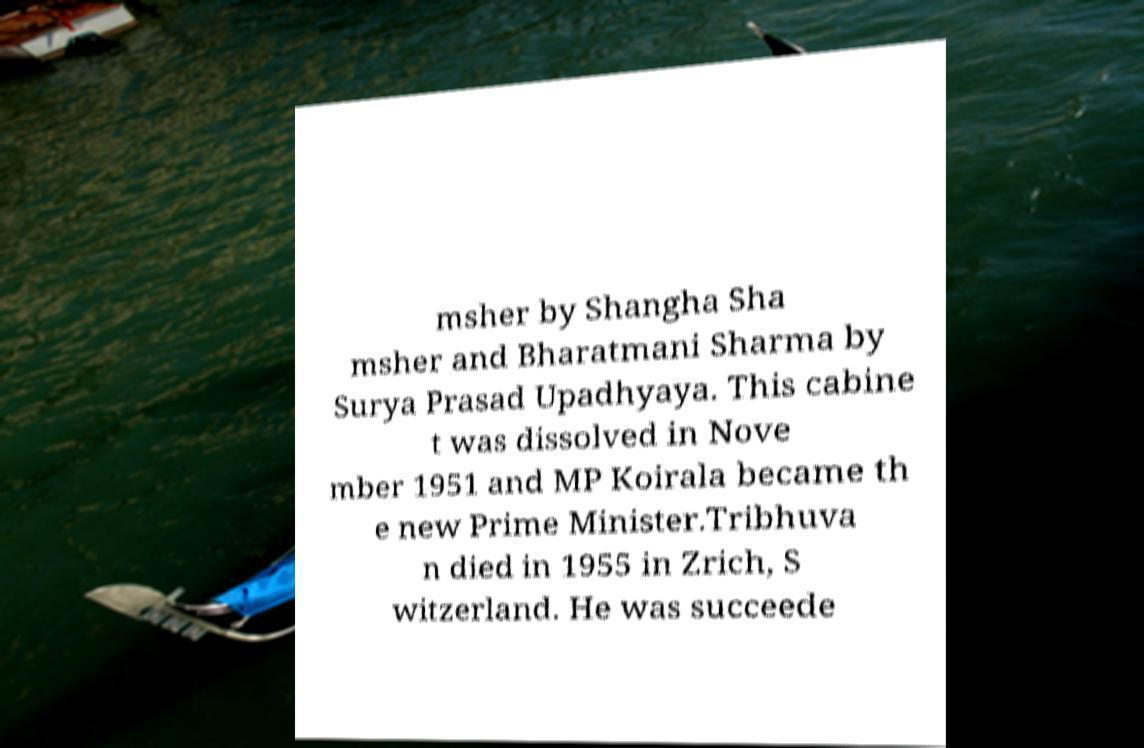Could you extract and type out the text from this image? msher by Shangha Sha msher and Bharatmani Sharma by Surya Prasad Upadhyaya. This cabine t was dissolved in Nove mber 1951 and MP Koirala became th e new Prime Minister.Tribhuva n died in 1955 in Zrich, S witzerland. He was succeede 